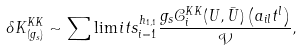<formula> <loc_0><loc_0><loc_500><loc_500>\delta K _ { ( g _ { s } ) } ^ { K K } \sim \sum \lim i t s _ { i = 1 } ^ { h _ { 1 , 1 } } \frac { g _ { s } \mathcal { C } _ { i } ^ { K K } ( U , \bar { U } ) \left ( a _ { i l } t ^ { l } \right ) } { \mathcal { V } } ,</formula> 